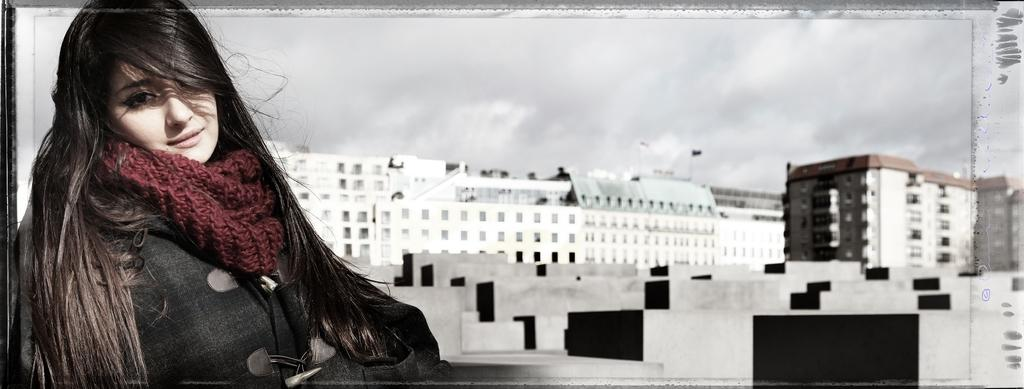Who is present in the image? There is a woman in the image. What structures can be seen in the image? There are buildings in the image. What can be seen in the background of the image? The sky is visible in the background of the image. How many kittens can be seen reading books in the image? There are no kittens or books present in the image. 